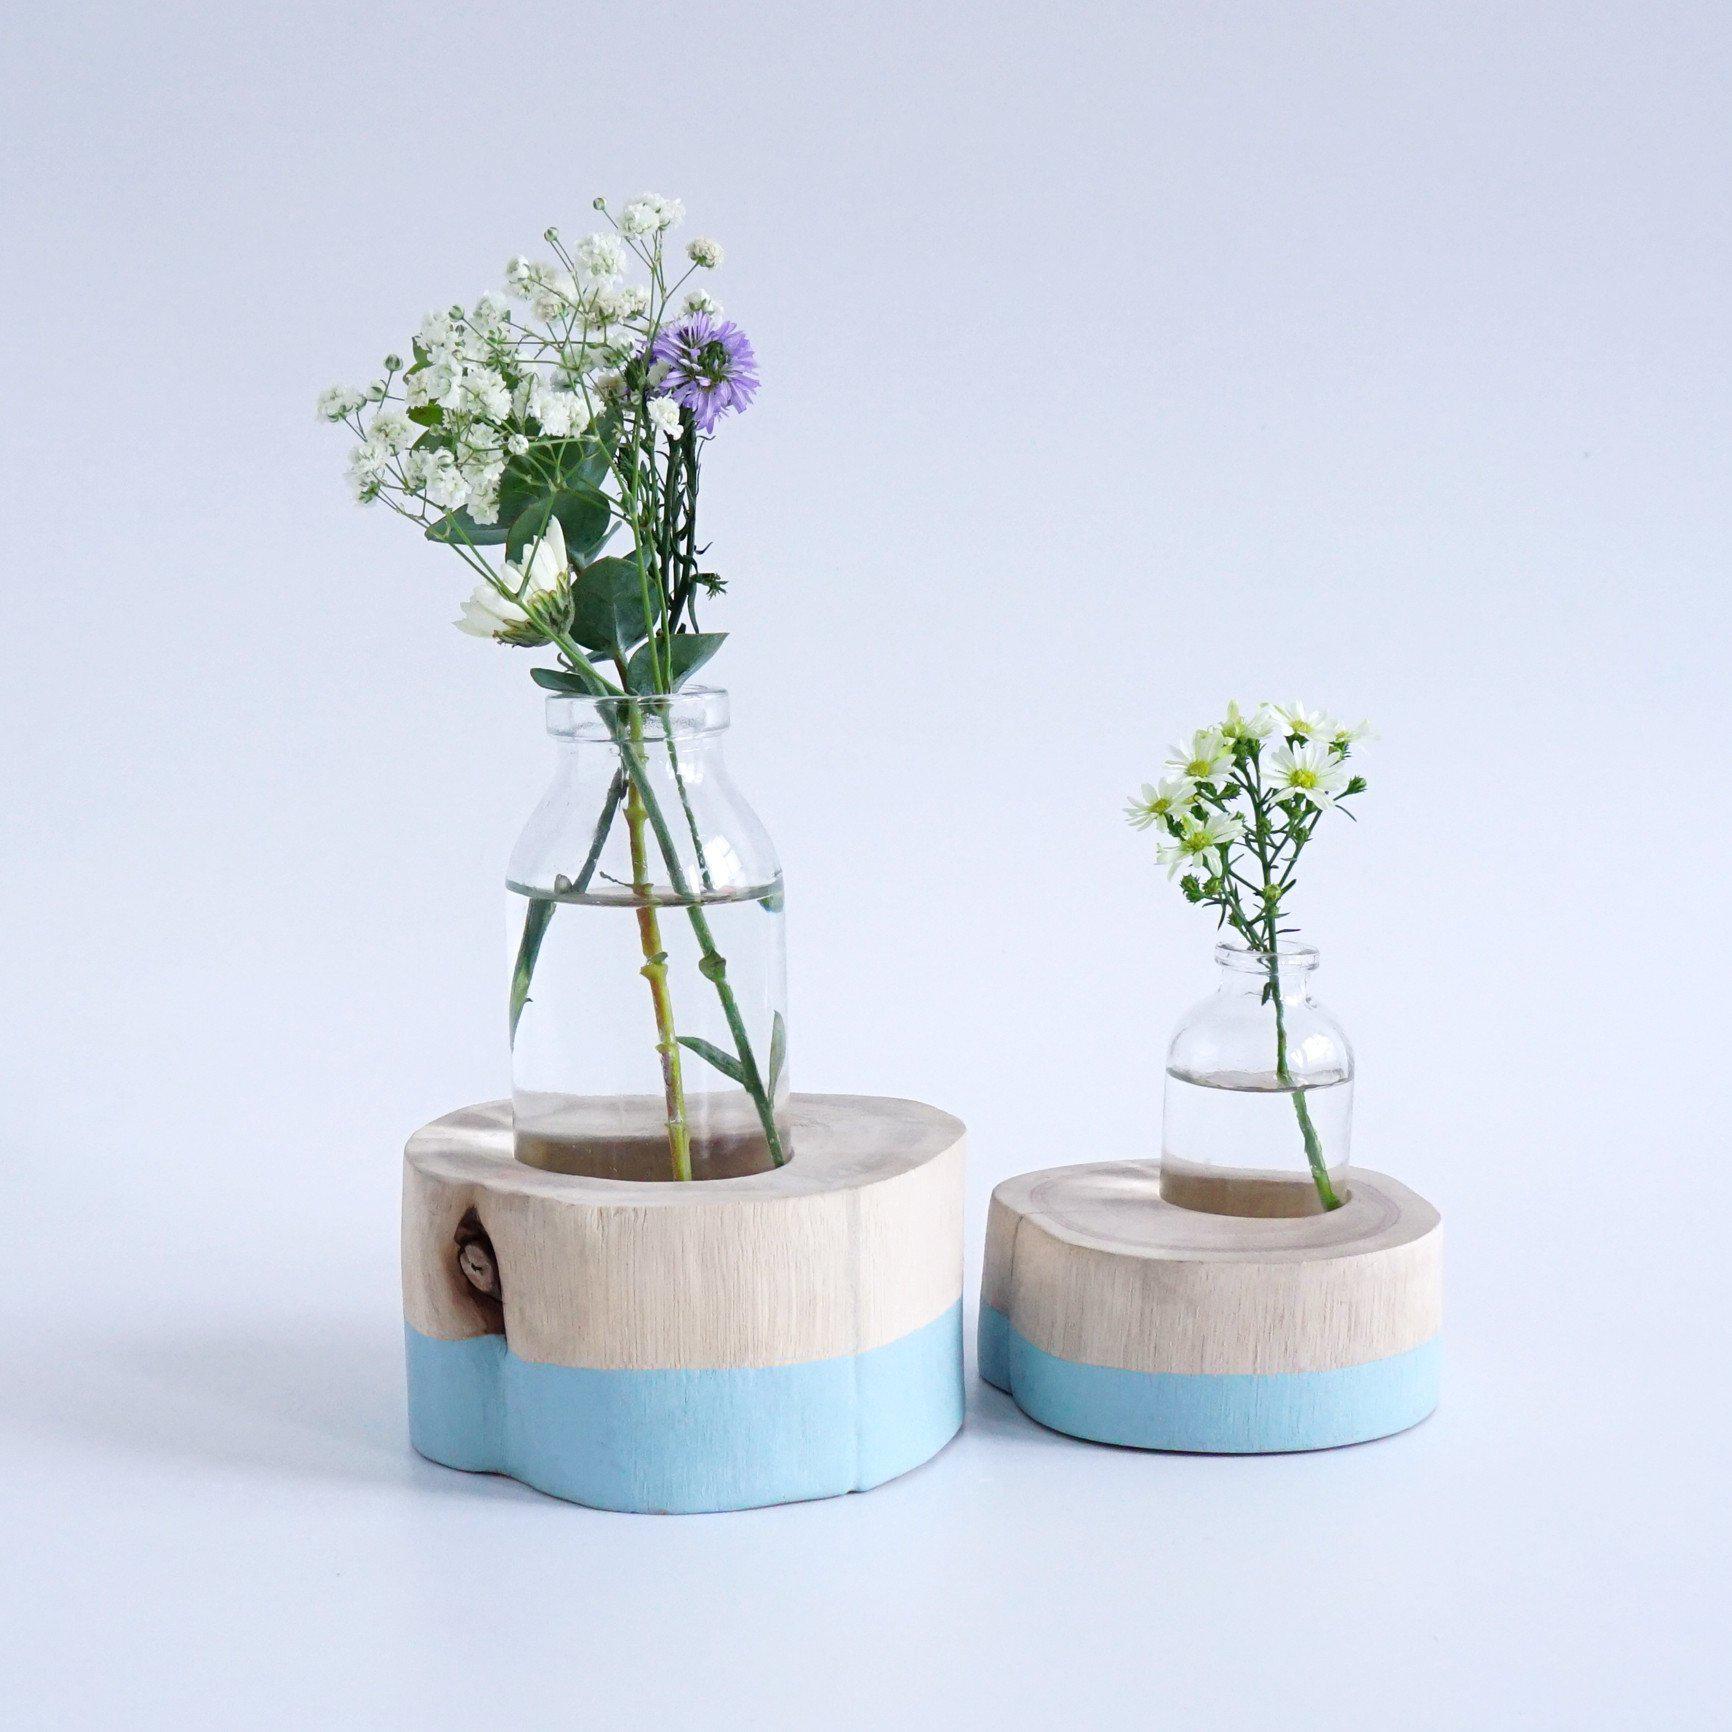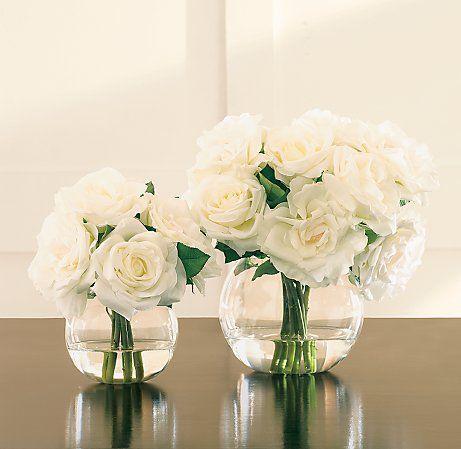The first image is the image on the left, the second image is the image on the right. Assess this claim about the two images: "There are two round, clear vases with flowers in them". Correct or not? Answer yes or no. Yes. The first image is the image on the left, the second image is the image on the right. Considering the images on both sides, is "there are pink flowers in a vase" valid? Answer yes or no. No. 